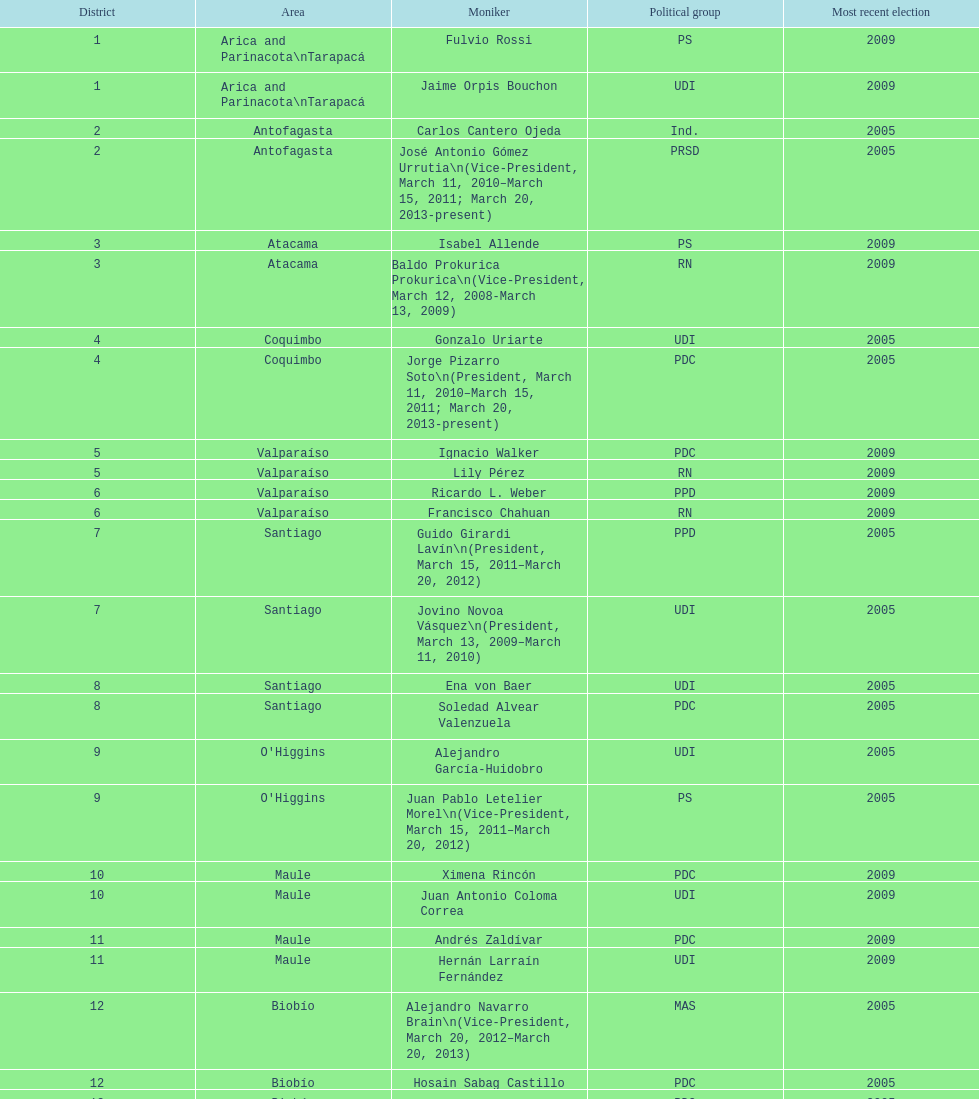Who was not last elected in either 2005 or 2009? Antonio Horvath Kiss. 